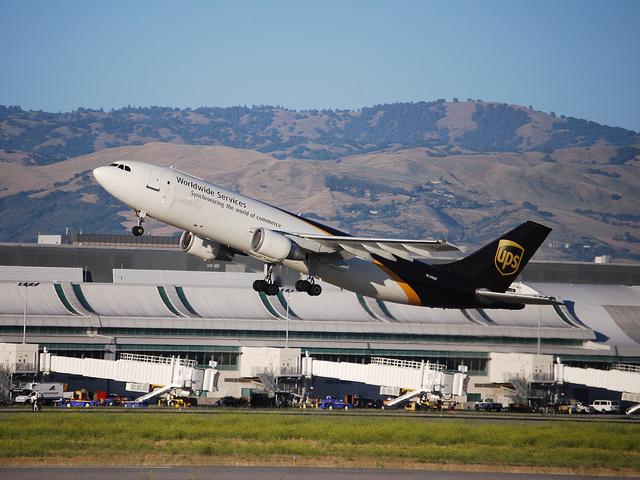What is pictured on the runway?
Short answer required. Airplane. Are there any mountains around?
Write a very short answer. Yes. Are there clouds?
Give a very brief answer. No. What type of plane is this?
Give a very brief answer. Ups. Is this plane parked?
Quick response, please. No. Is this airplane on display?
Be succinct. No. What is the plane doing?
Keep it brief. Taking off. What company owns this jet?
Give a very brief answer. Ups. Is there snow on the mountains?
Give a very brief answer. No. 